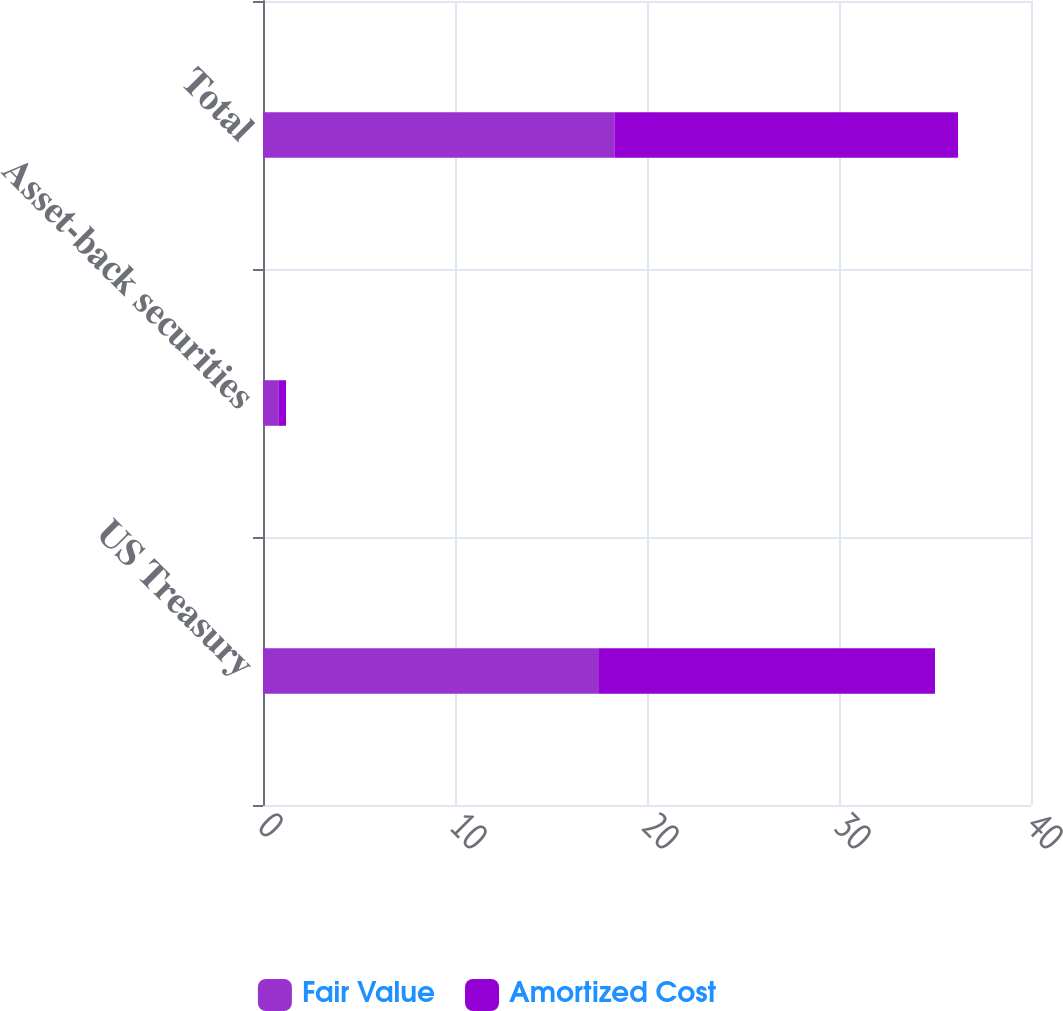<chart> <loc_0><loc_0><loc_500><loc_500><stacked_bar_chart><ecel><fcel>US Treasury<fcel>Asset-back securities<fcel>Total<nl><fcel>Fair Value<fcel>17.5<fcel>0.8<fcel>18.3<nl><fcel>Amortized Cost<fcel>17.5<fcel>0.4<fcel>17.9<nl></chart> 